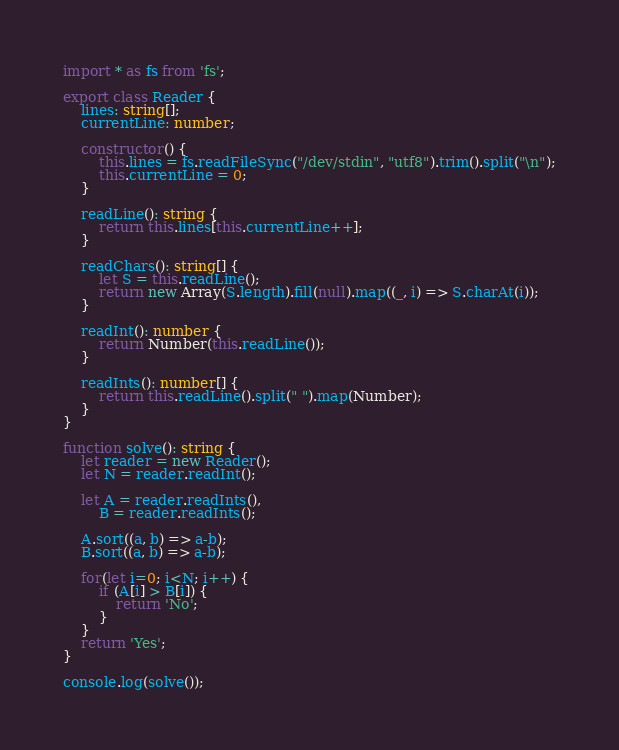Convert code to text. <code><loc_0><loc_0><loc_500><loc_500><_TypeScript_>import * as fs from 'fs';

export class Reader {
    lines: string[];
    currentLine: number;

    constructor() {
        this.lines = fs.readFileSync("/dev/stdin", "utf8").trim().split("\n");
        this.currentLine = 0;
    }

    readLine(): string {
        return this.lines[this.currentLine++];
    }

	readChars(): string[] {
		let S = this.readLine();
		return new Array(S.length).fill(null).map((_, i) => S.charAt(i));
	}

    readInt(): number {
        return Number(this.readLine());
    }

    readInts(): number[] {
        return this.readLine().split(" ").map(Number);
    }
} 

function solve(): string {
	let reader = new Reader();
	let N = reader.readInt();

	let A = reader.readInts(),
		B = reader.readInts();

	A.sort((a, b) => a-b);
	B.sort((a, b) => a-b);

	for(let i=0; i<N; i++) {
		if (A[i] > B[i]) {
			return 'No';
		}
	}
	return 'Yes';
}

console.log(solve());
</code> 